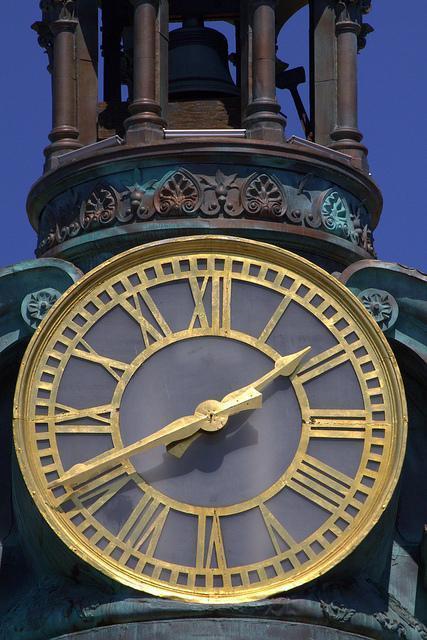How many people are wearing white shirt?
Give a very brief answer. 0. 